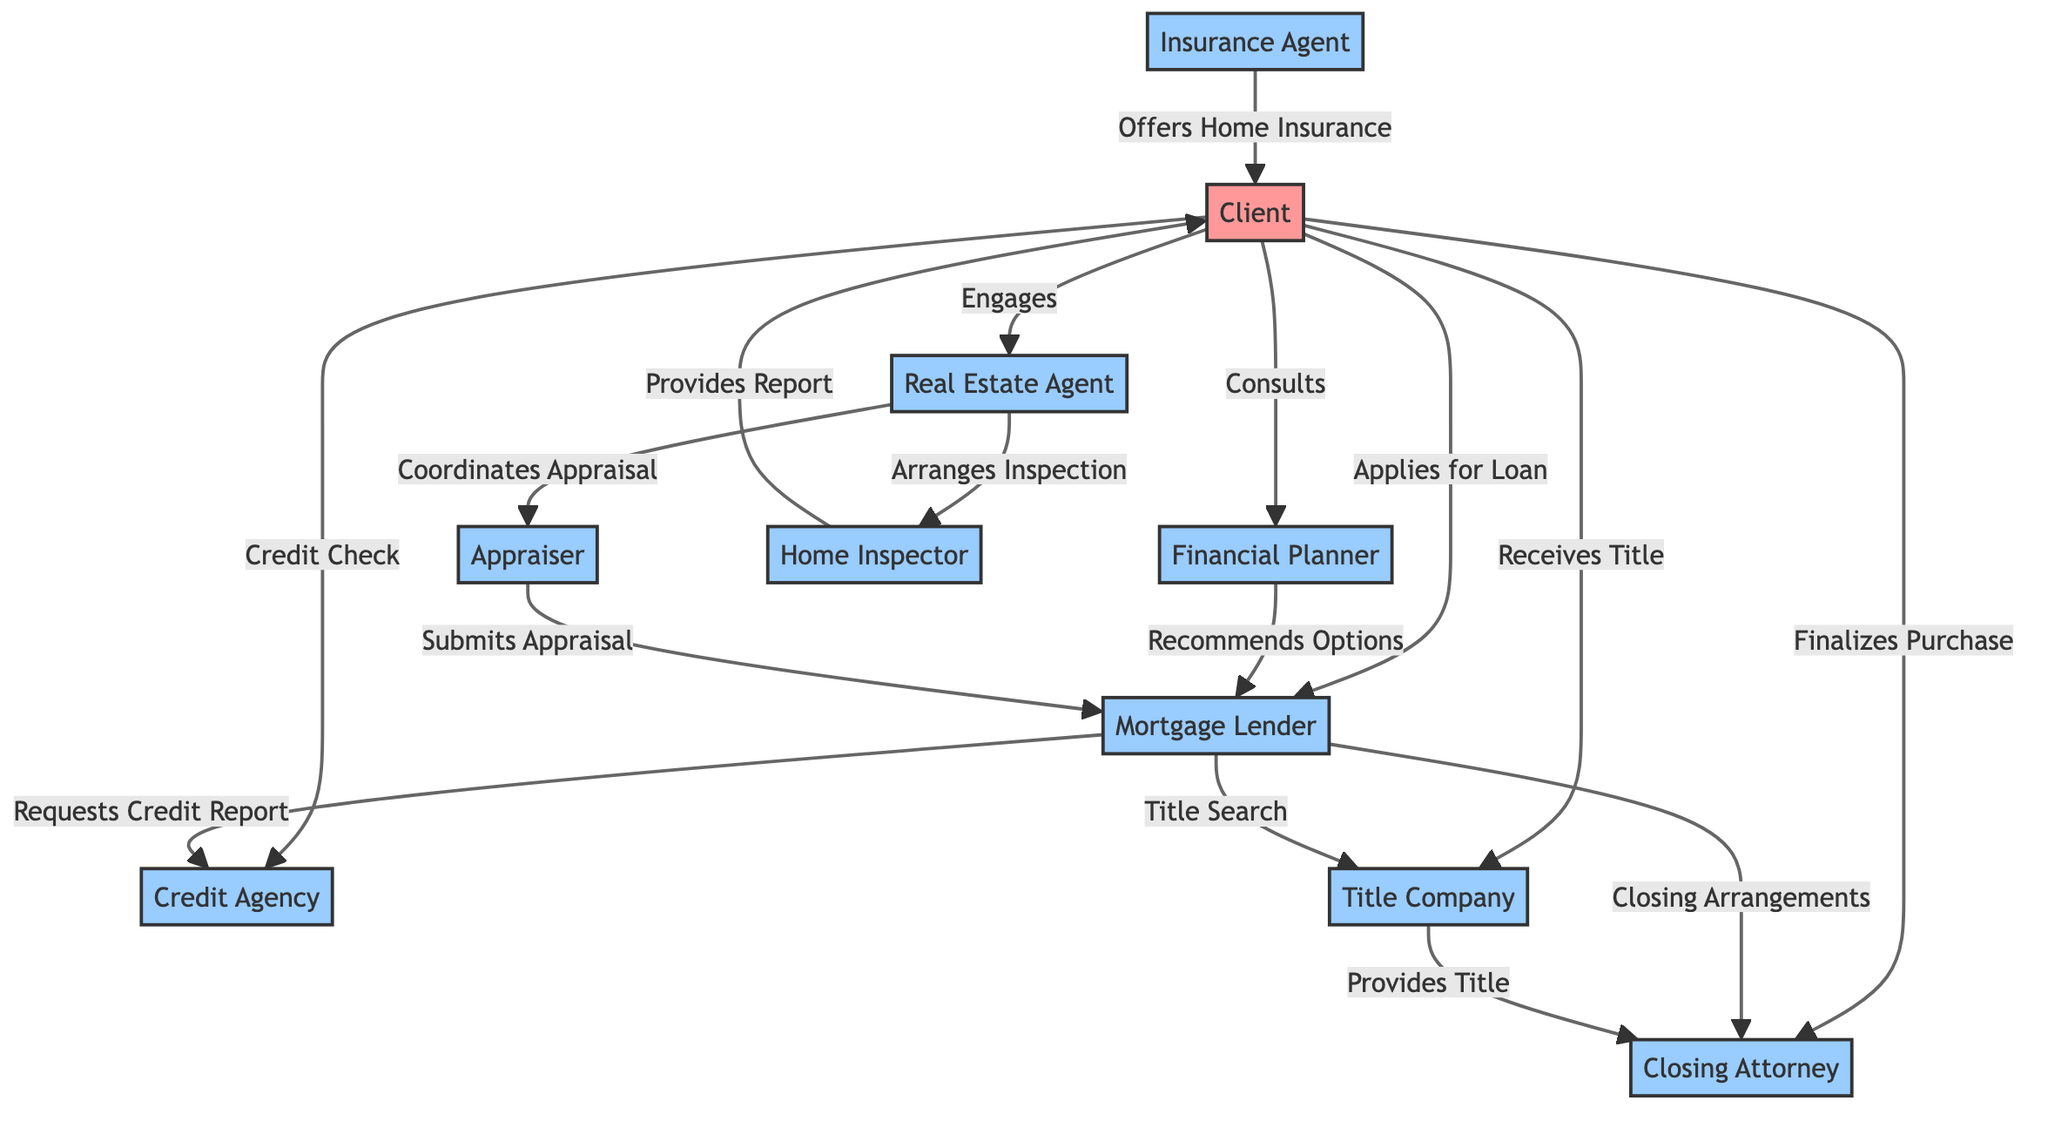What's the total number of nodes in the diagram? The diagram includes all unique entities involved in the mortgage process as nodes. Counting these entities, we find there are 10 nodes: Client, Financial Planner, Real Estate Agent, Mortgage Lender, Credit Agency, Title Company, Appraiser, Home Inspector, Insurance Agent, and Closing Attorney.
Answer: 10 What relationship does the Client have with the Financial Planner? The diagram shows a directed edge from Client to Financial Planner labeled "Consults," indicating that the Client consults with the Financial Planner for assistance in the mortgage process.
Answer: Consults Which two professionals are directly connected to Appraiser? The diagram shows that the Appraiser is connected to the Real Estate Agent (coordinates appraisal) and the Mortgage Lender (submits appraisal). Both connections are illustrated through directed edges.
Answer: Real Estate Agent and Mortgage Lender How many edges are there in total? Counting all the relationships (edges) connecting the nodes in the diagram provides the total number of edges. There are 15 directed edges representing the various interactions among the nodes.
Answer: 15 What is the role of the Title Company in the process? The Title Company is connected to the Mortgage Lender (title search), provides title to the Closing Attorney (provides title), and receives the client’s engagement (receives title). This involvement signifies its crucial role in ensuring clear title for the transaction.
Answer: Title Search and Provides Title How does the Home Inspector interact with the Client? The diagram illustrates that the Home Inspector provides a report to the Client directly. This relationship signifies the role of the Home Inspector in informing the Client about the condition of the property.
Answer: Provides Report What type of interaction exists between the Mortgage Lender and the Credit Agency? The directed edge from Mortgage Lender to Credit Agency labeled "Requests Credit Report" indicates the Mortgage Lender requests a credit report to assess the creditworthiness of the Client as part of the loan application process.
Answer: Requests Credit Report In how many instances does the Client engage with different entities? The diagram indicates multiple interactions of the Client with various nodes: they consult the Financial Planner, engage with the Real Estate Agent, conduct a credit check with the Credit Agency, apply for a loan with the Mortgage Lender, receive the title from the Title Company, and finalize the purchase with the Closing Attorney. This totals six distinct engagements.
Answer: 6 Which professionals provide services directly to the Client? The diagram shows two professionals providing services directly to the Client: the Home Inspector (provides report) and the Insurance Agent (offers home insurance). Thus, the Client has direct interactions with both.
Answer: Home Inspector and Insurance Agent 